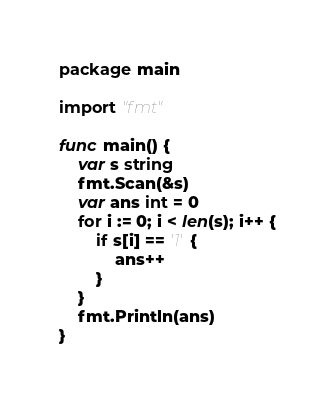Convert code to text. <code><loc_0><loc_0><loc_500><loc_500><_Go_>package main

import "fmt"

func main() {
	var s string
	fmt.Scan(&s)
	var ans int = 0
	for i := 0; i < len(s); i++ {
		if s[i] == '1' {
			ans++
		}
	}
	fmt.Println(ans)
}

</code> 